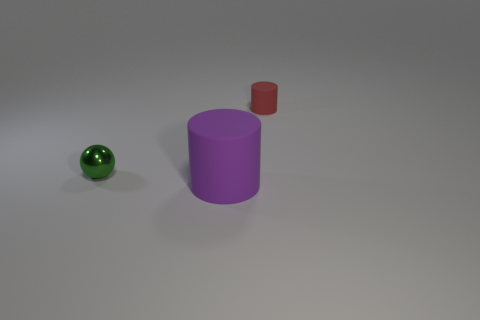How many objects are cylinders behind the green sphere or tiny objects behind the tiny metal sphere?
Your response must be concise. 1. Do the green shiny ball and the red object have the same size?
Give a very brief answer. Yes. What number of balls are gray metal things or tiny metal things?
Your response must be concise. 1. What number of rubber cylinders are both behind the green shiny thing and on the left side of the small rubber thing?
Offer a very short reply. 0. Do the green metal ball and the rubber cylinder that is behind the metallic thing have the same size?
Ensure brevity in your answer.  Yes. There is a object that is on the right side of the cylinder in front of the red thing; is there a tiny red rubber cylinder right of it?
Your response must be concise. No. The tiny thing that is right of the matte thing in front of the red thing is made of what material?
Keep it short and to the point. Rubber. The thing that is both on the left side of the tiny red rubber thing and behind the large purple object is made of what material?
Give a very brief answer. Metal. Are there any other tiny shiny things of the same shape as the small green metal thing?
Provide a short and direct response. No. Are there any tiny green balls in front of the cylinder in front of the tiny green shiny thing?
Give a very brief answer. No. 